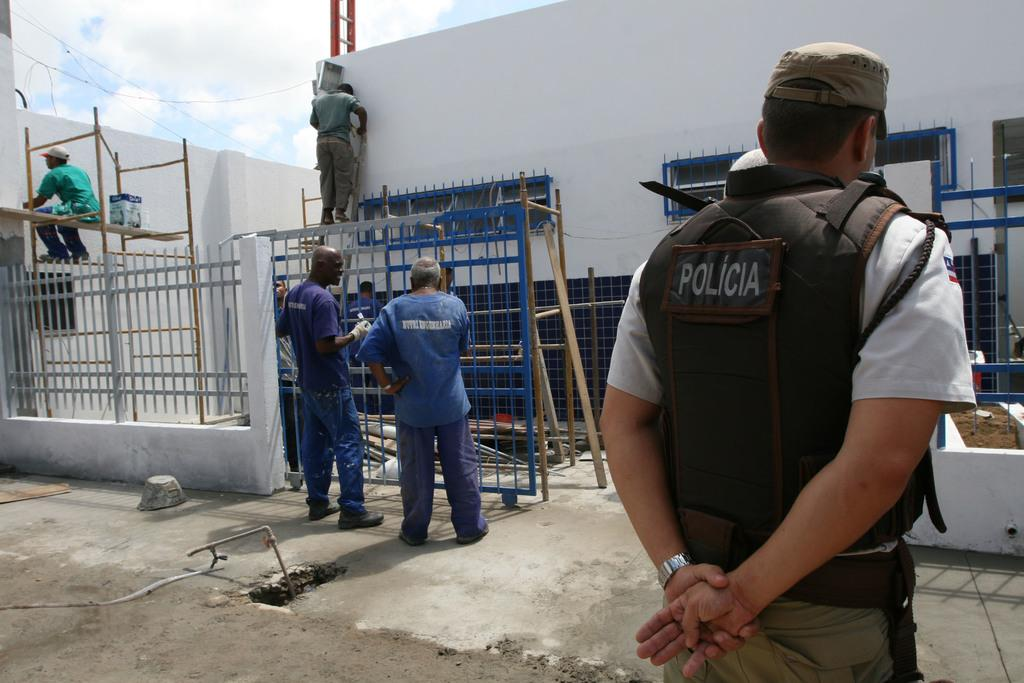What is the primary surface on which the people are standing in the image? The people are standing on the floor in the image. Are there any other surfaces on which people are standing? Yes, there are people standing on grills in the image. What can be seen in the background of the image? There are buildings and the sky visible in the background of the image. What is the condition of the sky in the image? The sky has clouds present in it. What type of boundary can be seen separating the people from the jail in the image? There is no jail present in the image, and therefore no boundary separating the people from it. 